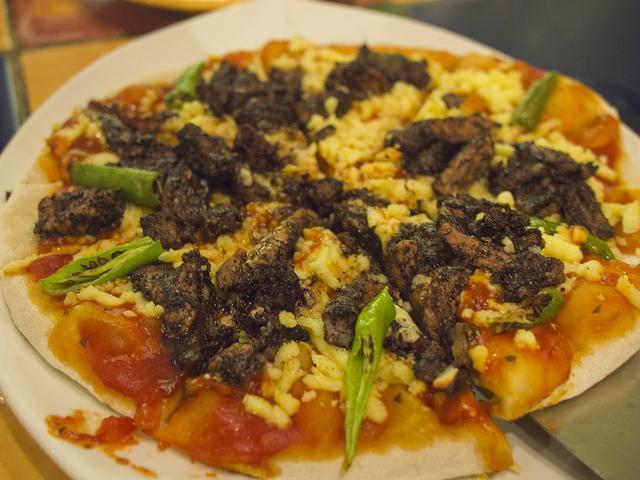How many people are wearing blue shirts?
Give a very brief answer. 0. 